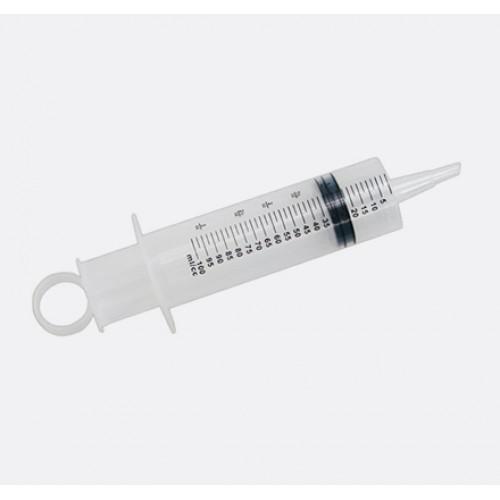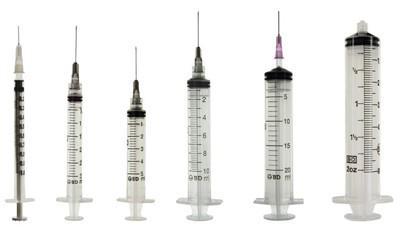The first image is the image on the left, the second image is the image on the right. Analyze the images presented: Is the assertion "One of the images shows only one syringe, and it has a ring on the end of it." valid? Answer yes or no. Yes. 